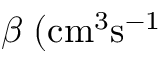<formula> <loc_0><loc_0><loc_500><loc_500>\beta \, ( { c m } ^ { 3 } \mathrm { { s } ^ { - 1 } }</formula> 